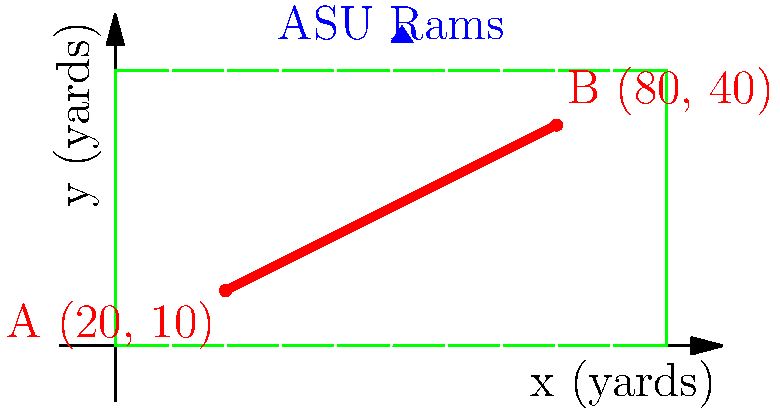During a crucial play, an Angelo State Rams wide receiver runs a route from point A (20, 10) to point B (80, 40) on the football field, as shown in the diagram. Calculate the slope of the line representing the player's route. What does this slope indicate about the player's movement on the field? To find the slope of the line representing the player's route, we'll use the slope formula:

$$ \text{slope} = m = \frac{y_2 - y_1}{x_2 - x_1} $$

Where $(x_1, y_1)$ is the starting point A, and $(x_2, y_2)$ is the ending point B.

Step 1: Identify the coordinates
- Point A: $(x_1, y_1) = (20, 10)$
- Point B: $(x_2, y_2) = (80, 40)$

Step 2: Apply the slope formula
$$ m = \frac{40 - 10}{80 - 20} = \frac{30}{60} = \frac{1}{2} = 0.5 $$

Step 3: Interpret the result
The slope of 0.5 means that for every 1 yard the player moves horizontally (along the x-axis), they move 0.5 yards vertically (along the y-axis). In football terms, this indicates that the player is running upfield at a diagonal angle, gaining 5 yards in depth for every 10 yards they move across the field.

This positive slope shows that the player is running a route that moves both forward (towards the opponent's end zone) and outward (towards the sideline) simultaneously, which could be part of a strategically designed play to create separation from defenders or open up space for other receivers.
Answer: 0.5; indicates upfield diagonal movement, gaining 5 yards depth per 10 yards across. 